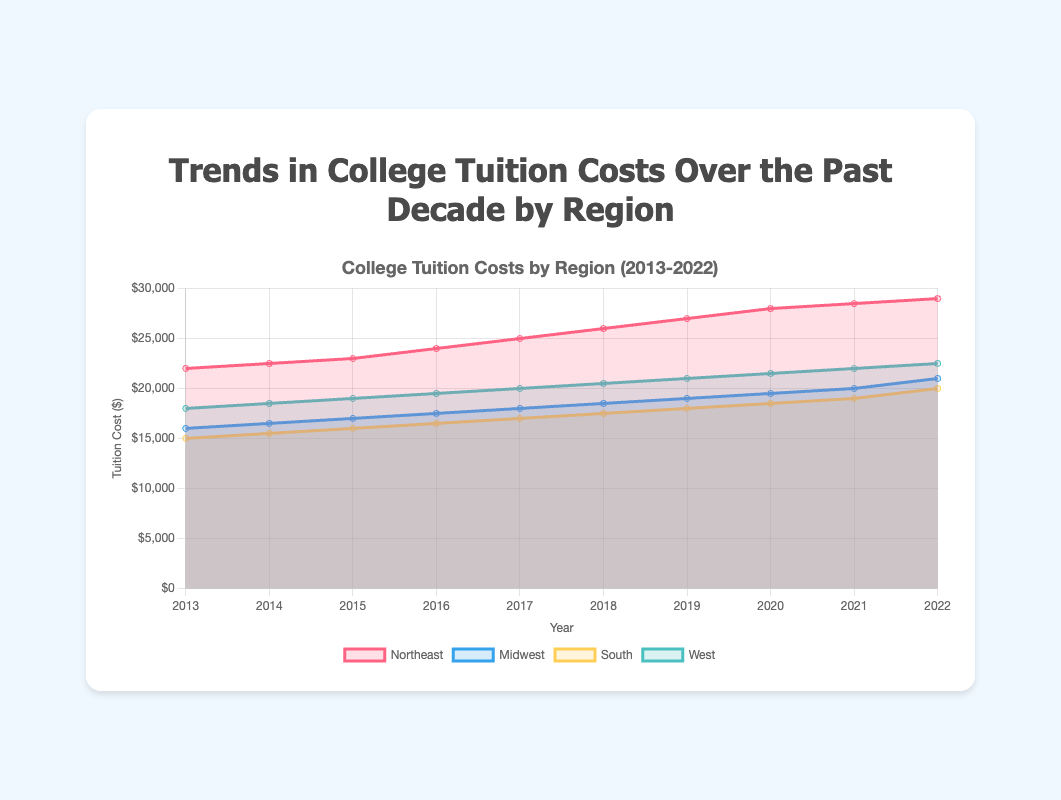What is the title of the chart? The title of the chart is located at the top, in the center, as it typically summarizes the content of the chart. Here, it clearly states the overall topic being represented in the chart.
Answer: Trends in College Tuition Costs Over the Past Decade by Region What is the tuition cost in the Midwest region for the year 2015? To find the answer, locate the Midwest dataset in the chart and then find the value corresponding to the year 2015.
Answer: $17000 What was the general trend in college tuition costs in the West region from 2013 to 2022? To answer this, observe the line representing the West region across the years from 2013 to 2022. Notice if the line increases, decreases, or remains stable over this period.
Answer: Increasing Which region had the highest tuition cost in 2022? Compare the endpoints for all regions in the year 2022. Identify the highest point.
Answer: Northeast How much did the tuition cost in the South region increase from 2017 to 2022? Find the tuition costs for the South region in both 2017 and 2022, then calculate the difference between these two values: 20000 (2022) - 17000 (2017)
Answer: $3000 In which year did the Northeast region exceed $25000 in tuition costs? Look for the point where the Northeast dataset crosses the $25000 mark on the y-axis.
Answer: 2017 Which region had the smallest increase in tuition costs over the past decade? Calculate the difference between the starting and ending points of each region's dataset and compare these differences. The smallest difference indicates the smallest cost increase.
Answer: South Compare the tuition costs of the Northeast and Midwest regions in 2016. Which region had higher tuition costs? Locate the data points for both the Northeast and Midwest regions for the year 2016 and compare their values.
Answer: Northeast What was the average tuition cost in the Northeast region over the entire period? Add the tuition costs for all the years in the Northeast region dataset and divide by the number of years (10). (22000 + 22500 + 23000 + 24000 + 25000 + 26000 + 27000 + 28000 + 28500 + 29000) / 10 = 25500
Answer: $25500 During which period did the Midwest region see a steady increase in tuition costs? Examine the Midwest region's line on the chart to identify any long period without major fluctuations where the line steadily increases.
Answer: Throughout 2013-2022 